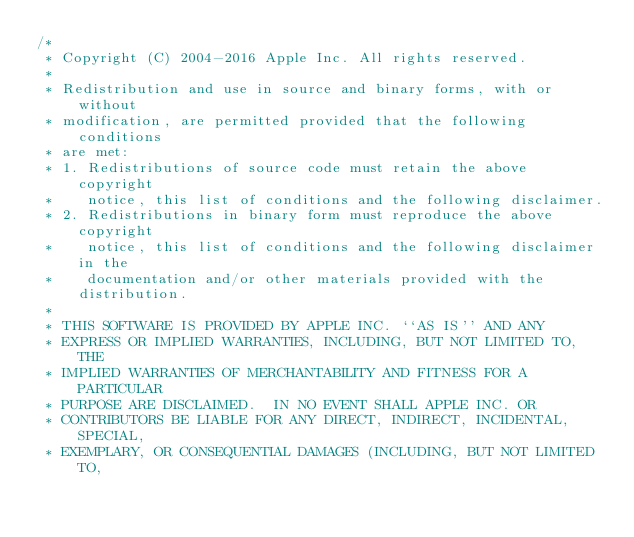Convert code to text. <code><loc_0><loc_0><loc_500><loc_500><_ObjectiveC_>/*
 * Copyright (C) 2004-2016 Apple Inc. All rights reserved.
 *
 * Redistribution and use in source and binary forms, with or without
 * modification, are permitted provided that the following conditions
 * are met:
 * 1. Redistributions of source code must retain the above copyright
 *    notice, this list of conditions and the following disclaimer.
 * 2. Redistributions in binary form must reproduce the above copyright
 *    notice, this list of conditions and the following disclaimer in the
 *    documentation and/or other materials provided with the distribution.
 *
 * THIS SOFTWARE IS PROVIDED BY APPLE INC. ``AS IS'' AND ANY
 * EXPRESS OR IMPLIED WARRANTIES, INCLUDING, BUT NOT LIMITED TO, THE
 * IMPLIED WARRANTIES OF MERCHANTABILITY AND FITNESS FOR A PARTICULAR
 * PURPOSE ARE DISCLAIMED.  IN NO EVENT SHALL APPLE INC. OR
 * CONTRIBUTORS BE LIABLE FOR ANY DIRECT, INDIRECT, INCIDENTAL, SPECIAL,
 * EXEMPLARY, OR CONSEQUENTIAL DAMAGES (INCLUDING, BUT NOT LIMITED TO,</code> 